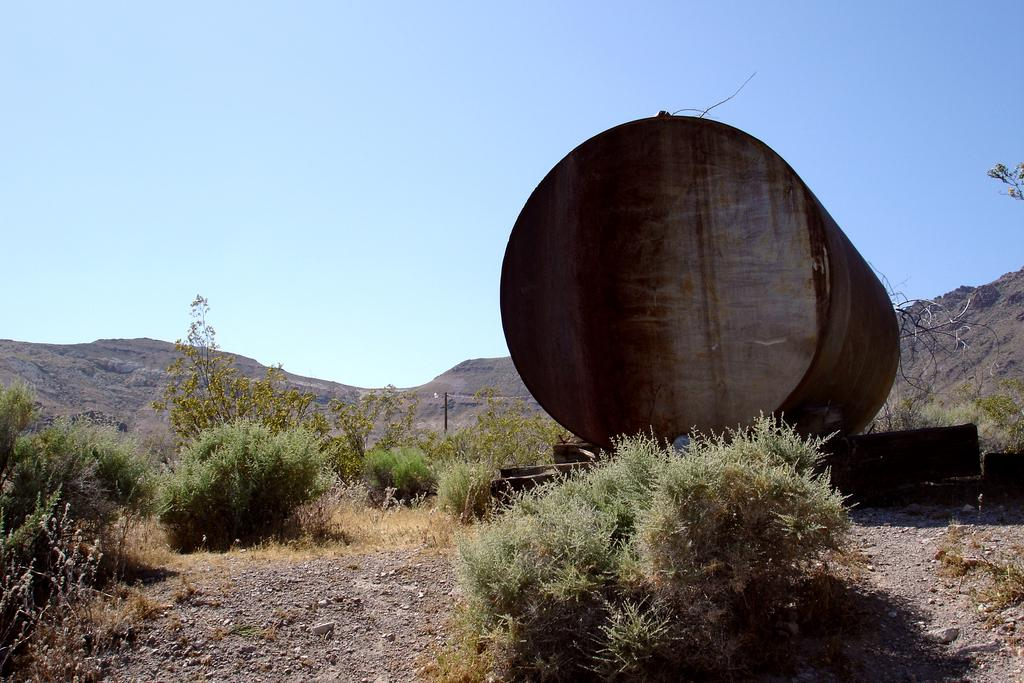What is located on the right side of the image? There is a container on the right side of the image. What type of vegetation is present in the image? There are plants on the ground in the image. What can be seen in the distance in the image? There are hills visible in the background of the image. What is visible above the hills in the image? The sky is visible in the background of the image. What type of boot is being worn by the lawyer in the image? There is no lawyer or boot present in the image. 